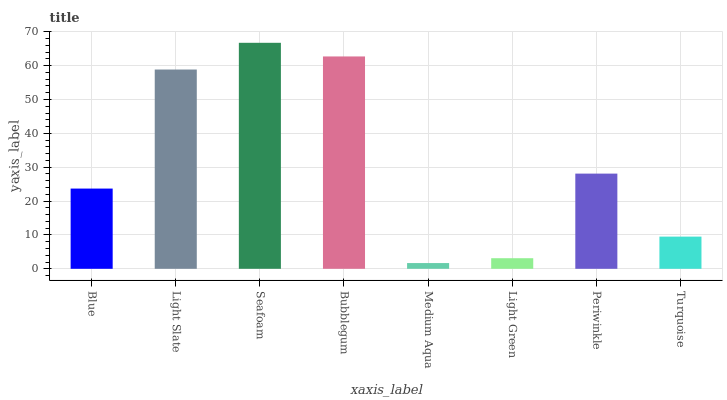Is Medium Aqua the minimum?
Answer yes or no. Yes. Is Seafoam the maximum?
Answer yes or no. Yes. Is Light Slate the minimum?
Answer yes or no. No. Is Light Slate the maximum?
Answer yes or no. No. Is Light Slate greater than Blue?
Answer yes or no. Yes. Is Blue less than Light Slate?
Answer yes or no. Yes. Is Blue greater than Light Slate?
Answer yes or no. No. Is Light Slate less than Blue?
Answer yes or no. No. Is Periwinkle the high median?
Answer yes or no. Yes. Is Blue the low median?
Answer yes or no. Yes. Is Light Slate the high median?
Answer yes or no. No. Is Light Green the low median?
Answer yes or no. No. 